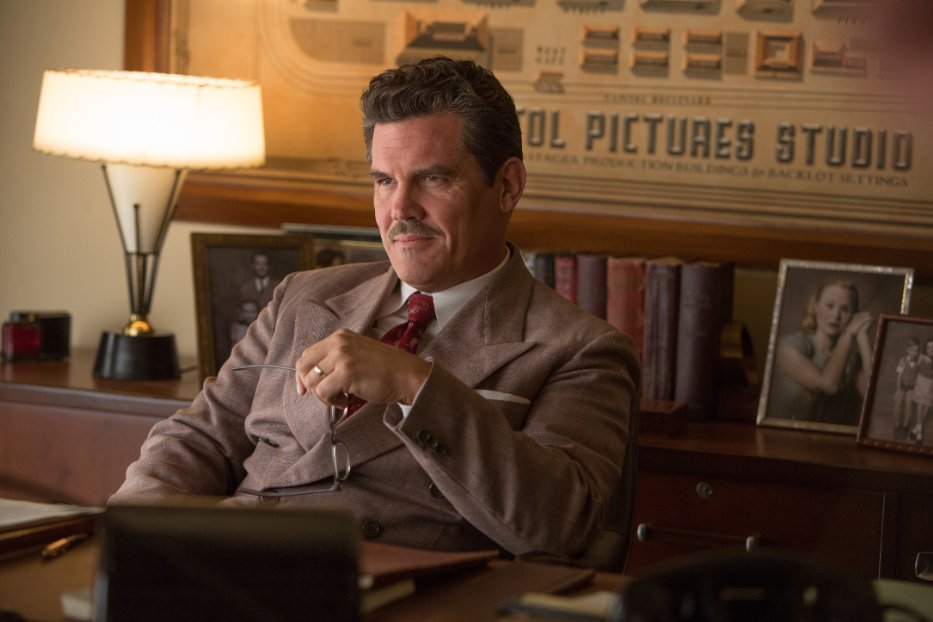Can you describe the emotional atmosphere of this scene? The emotional atmosphere in this scene feels quite tense and introspective. The actor’s serious expression, coupled with the subdued, warm lighting of the vintage office, conveys a sense of gravity and contemplation. It's as if he's on the brink of making a significant decision or reflecting on a complex problem that requires his deep thought and attention. 